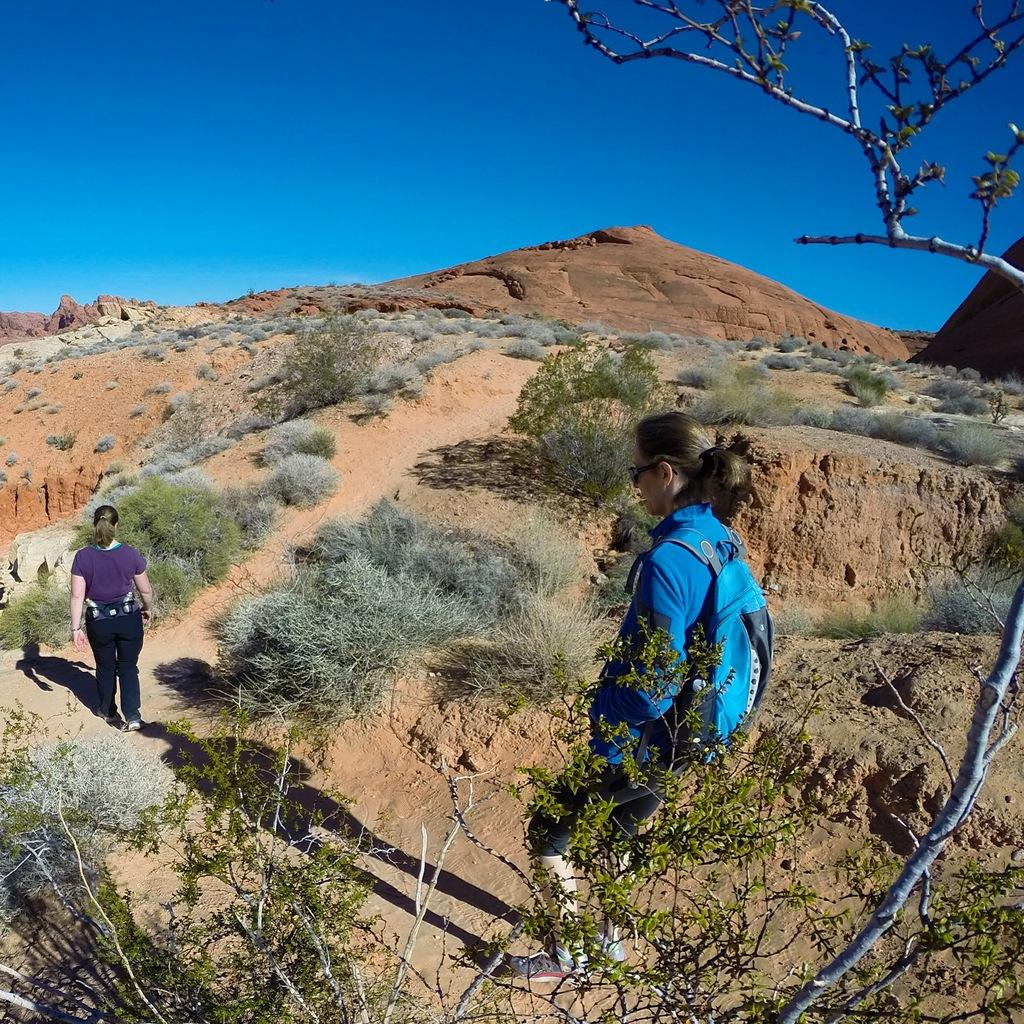Who is present in the image? There are women in the image. What type of terrain is visible in the image? There is grass, plants, trees, a hill, and rocks in the image. What part of the natural environment is visible in the image? The sky is visible in the image. What type of stick can be seen in the image? There is no stick present in the image. What is the range of the trees in the image? The range of the trees cannot be determined from the image, as it only shows a snapshot of the scene. 